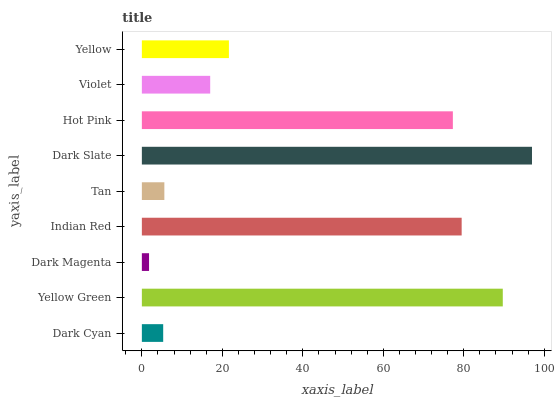Is Dark Magenta the minimum?
Answer yes or no. Yes. Is Dark Slate the maximum?
Answer yes or no. Yes. Is Yellow Green the minimum?
Answer yes or no. No. Is Yellow Green the maximum?
Answer yes or no. No. Is Yellow Green greater than Dark Cyan?
Answer yes or no. Yes. Is Dark Cyan less than Yellow Green?
Answer yes or no. Yes. Is Dark Cyan greater than Yellow Green?
Answer yes or no. No. Is Yellow Green less than Dark Cyan?
Answer yes or no. No. Is Yellow the high median?
Answer yes or no. Yes. Is Yellow the low median?
Answer yes or no. Yes. Is Dark Slate the high median?
Answer yes or no. No. Is Tan the low median?
Answer yes or no. No. 